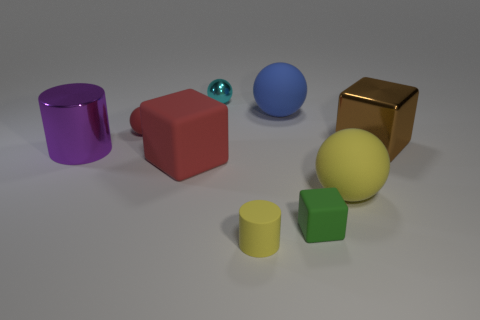Is the color of the matte cylinder the same as the ball on the right side of the large blue sphere?
Offer a terse response. Yes. Are there fewer large purple cylinders that are behind the cyan ball than large green metallic cylinders?
Make the answer very short. No. What number of other objects are the same size as the purple cylinder?
Your answer should be very brief. 4. Do the metallic thing that is to the right of the large blue rubber sphere and the big red thing have the same shape?
Ensure brevity in your answer.  Yes. Are there more big spheres that are behind the yellow sphere than large purple cubes?
Your answer should be very brief. Yes. What material is the object that is behind the big matte block and to the right of the tiny green object?
Provide a succinct answer. Metal. Is there anything else that is the same shape as the big yellow object?
Your response must be concise. Yes. What number of shiny objects are behind the big brown block and on the left side of the large rubber cube?
Your response must be concise. 0. What is the material of the small green thing?
Provide a succinct answer. Rubber. Are there the same number of small rubber things that are on the left side of the blue object and large balls?
Ensure brevity in your answer.  Yes. 